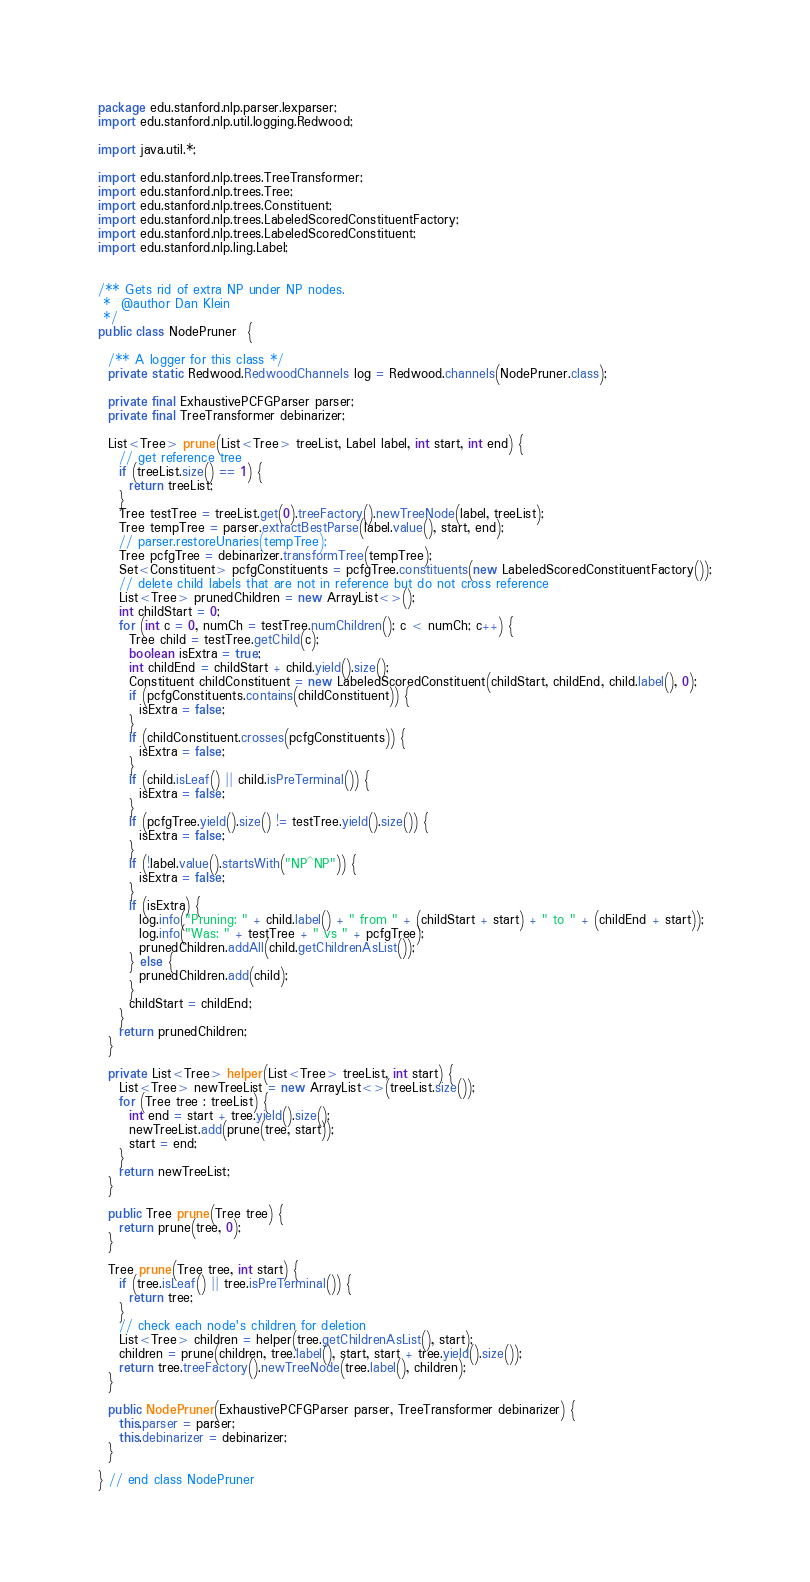Convert code to text. <code><loc_0><loc_0><loc_500><loc_500><_Java_>package edu.stanford.nlp.parser.lexparser; 
import edu.stanford.nlp.util.logging.Redwood;

import java.util.*;

import edu.stanford.nlp.trees.TreeTransformer;
import edu.stanford.nlp.trees.Tree;
import edu.stanford.nlp.trees.Constituent;
import edu.stanford.nlp.trees.LabeledScoredConstituentFactory;
import edu.stanford.nlp.trees.LabeledScoredConstituent;
import edu.stanford.nlp.ling.Label;


/** Gets rid of extra NP under NP nodes.
 *  @author Dan Klein
 */
public class NodePruner  {

  /** A logger for this class */
  private static Redwood.RedwoodChannels log = Redwood.channels(NodePruner.class);

  private final ExhaustivePCFGParser parser;
  private final TreeTransformer debinarizer;

  List<Tree> prune(List<Tree> treeList, Label label, int start, int end) {
    // get reference tree
    if (treeList.size() == 1) {
      return treeList;
    }
    Tree testTree = treeList.get(0).treeFactory().newTreeNode(label, treeList);
    Tree tempTree = parser.extractBestParse(label.value(), start, end);
    // parser.restoreUnaries(tempTree);
    Tree pcfgTree = debinarizer.transformTree(tempTree);
    Set<Constituent> pcfgConstituents = pcfgTree.constituents(new LabeledScoredConstituentFactory());
    // delete child labels that are not in reference but do not cross reference
    List<Tree> prunedChildren = new ArrayList<>();
    int childStart = 0;
    for (int c = 0, numCh = testTree.numChildren(); c < numCh; c++) {
      Tree child = testTree.getChild(c);
      boolean isExtra = true;
      int childEnd = childStart + child.yield().size();
      Constituent childConstituent = new LabeledScoredConstituent(childStart, childEnd, child.label(), 0);
      if (pcfgConstituents.contains(childConstituent)) {
        isExtra = false;
      }
      if (childConstituent.crosses(pcfgConstituents)) {
        isExtra = false;
      }
      if (child.isLeaf() || child.isPreTerminal()) {
        isExtra = false;
      }
      if (pcfgTree.yield().size() != testTree.yield().size()) {
        isExtra = false;
      }
      if (!label.value().startsWith("NP^NP")) {
        isExtra = false;
      }
      if (isExtra) {
        log.info("Pruning: " + child.label() + " from " + (childStart + start) + " to " + (childEnd + start));
        log.info("Was: " + testTree + " vs " + pcfgTree);
        prunedChildren.addAll(child.getChildrenAsList());
      } else {
        prunedChildren.add(child);
      }
      childStart = childEnd;
    }
    return prunedChildren;
  }

  private List<Tree> helper(List<Tree> treeList, int start) {
    List<Tree> newTreeList = new ArrayList<>(treeList.size());
    for (Tree tree : treeList) {
      int end = start + tree.yield().size();
      newTreeList.add(prune(tree, start));
      start = end;
    }
    return newTreeList;
  }

  public Tree prune(Tree tree) {
    return prune(tree, 0);
  }

  Tree prune(Tree tree, int start) {
    if (tree.isLeaf() || tree.isPreTerminal()) {
      return tree;
    }
    // check each node's children for deletion
    List<Tree> children = helper(tree.getChildrenAsList(), start);
    children = prune(children, tree.label(), start, start + tree.yield().size());
    return tree.treeFactory().newTreeNode(tree.label(), children);
  }

  public NodePruner(ExhaustivePCFGParser parser, TreeTransformer debinarizer) {
    this.parser = parser;
    this.debinarizer = debinarizer;
  }

} // end class NodePruner
</code> 